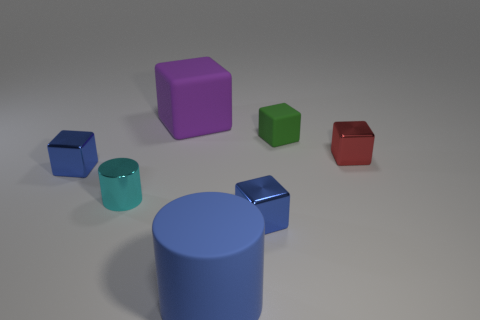The cylinder that is the same material as the red object is what size?
Provide a short and direct response. Small. What is the color of the large object that is to the right of the purple matte cube that is behind the red shiny block?
Offer a terse response. Blue. How many cubes have the same material as the large purple thing?
Ensure brevity in your answer.  1. What number of metal objects are small cubes or blue things?
Offer a very short reply. 3. There is a red cube that is the same size as the cyan object; what material is it?
Your answer should be very brief. Metal. Is there a big block that has the same material as the tiny red thing?
Offer a very short reply. No. What is the shape of the blue object that is right of the blue thing in front of the blue shiny block that is on the right side of the big blue cylinder?
Provide a short and direct response. Cube. Does the purple rubber block have the same size as the metal thing to the right of the small green rubber thing?
Offer a very short reply. No. There is a object that is right of the big rubber cylinder and in front of the cyan cylinder; what is its shape?
Make the answer very short. Cube. What number of small things are blue metallic objects or purple rubber cubes?
Provide a succinct answer. 2. 